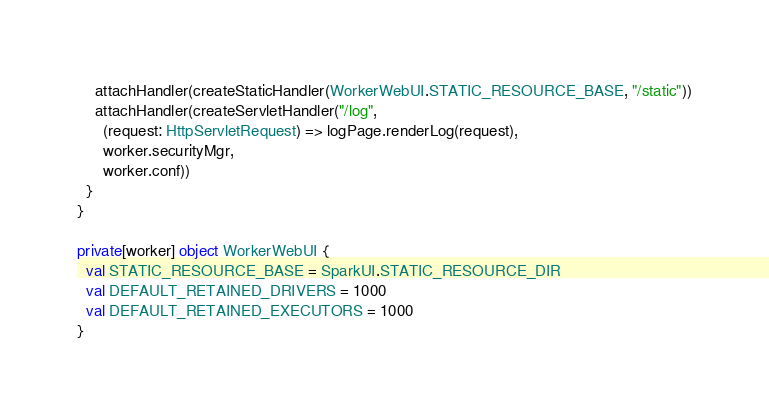<code> <loc_0><loc_0><loc_500><loc_500><_Scala_>    attachHandler(createStaticHandler(WorkerWebUI.STATIC_RESOURCE_BASE, "/static"))
    attachHandler(createServletHandler("/log",
      (request: HttpServletRequest) => logPage.renderLog(request),
      worker.securityMgr,
      worker.conf))
  }
}

private[worker] object WorkerWebUI {
  val STATIC_RESOURCE_BASE = SparkUI.STATIC_RESOURCE_DIR
  val DEFAULT_RETAINED_DRIVERS = 1000
  val DEFAULT_RETAINED_EXECUTORS = 1000
}
</code> 